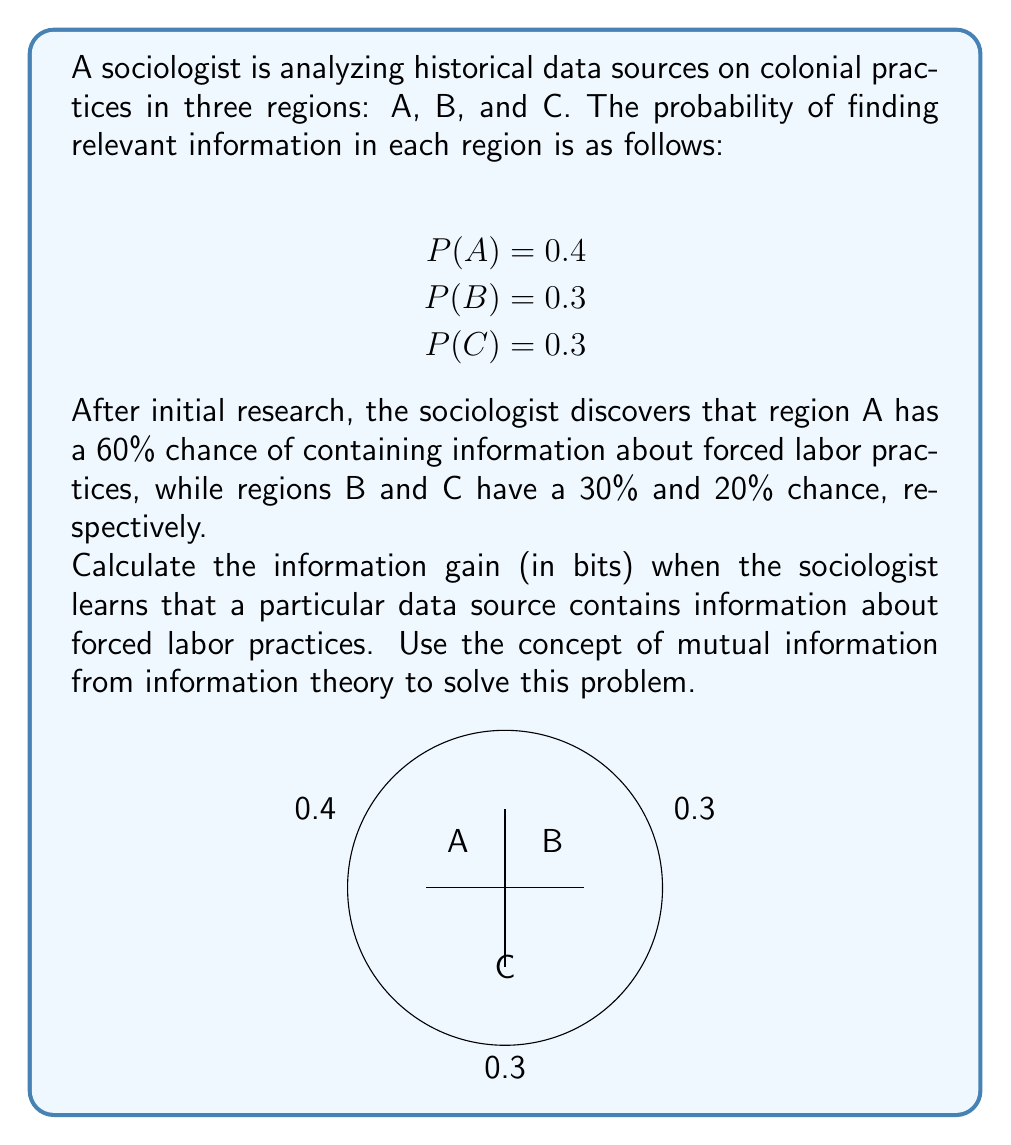What is the answer to this math problem? To calculate the information gain, we need to use the concept of mutual information. Let's follow these steps:

1. Define our variables:
   X: The region (A, B, or C)
   Y: Presence of forced labor information (1 if present, 0 if not)

2. Calculate P(Y=1) - the probability of finding forced labor information:
   P(Y=1) = P(A) * P(Y=1|A) + P(B) * P(Y=1|B) + P(C) * P(Y=1|C)
   P(Y=1) = 0.4 * 0.6 + 0.3 * 0.3 + 0.3 * 0.2
   P(Y=1) = 0.24 + 0.09 + 0.06 = 0.39

3. Calculate P(Y=0):
   P(Y=0) = 1 - P(Y=1) = 1 - 0.39 = 0.61

4. Calculate P(X|Y=1) for each region:
   P(A|Y=1) = P(Y=1|A) * P(A) / P(Y=1) = 0.6 * 0.4 / 0.39 ≈ 0.6154
   P(B|Y=1) = P(Y=1|B) * P(B) / P(Y=1) = 0.3 * 0.3 / 0.39 ≈ 0.2308
   P(C|Y=1) = P(Y=1|C) * P(C) / P(Y=1) = 0.2 * 0.3 / 0.39 ≈ 0.1538

5. Calculate the mutual information:
   I(X;Y) = ∑ P(x,y) * log2(P(x|y) / P(x))
   
   For Y=1:
   I(X;Y=1) = 0.24 * log2(0.6154/0.4) + 0.09 * log2(0.2308/0.3) + 0.06 * log2(0.1538/0.3)
             ≈ 0.24 * 0.6214 + 0.09 * (-0.3785) + 0.06 * (-0.9650)
             ≈ 0.1491 - 0.0341 - 0.0579
             ≈ 0.0571 bits

   For Y=0 (we need this for completeness):
   I(X;Y=0) = 0.16 * log2(0.2623/0.4) + 0.21 * log2(0.3443/0.3) + 0.24 * log2(0.3934/0.3)
             ≈ -0.0386 + 0.0200 + 0.0700
             ≈ 0.0514 bits

6. Sum the mutual information:
   I(X;Y) = I(X;Y=1) + I(X;Y=0) ≈ 0.0571 + 0.0514 = 0.1085 bits

The information gain is approximately 0.1085 bits.
Answer: 0.1085 bits 